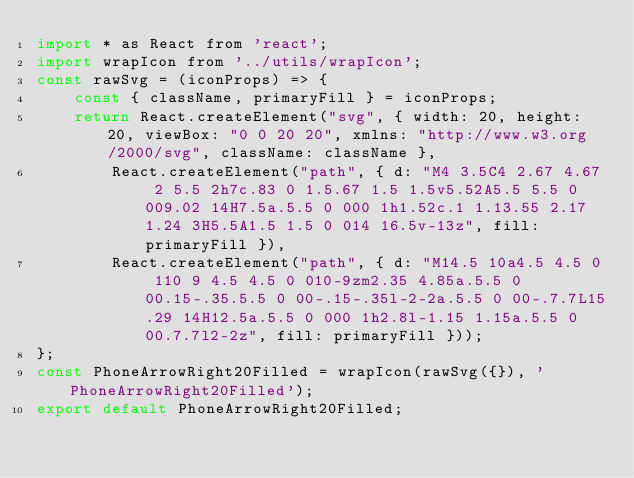<code> <loc_0><loc_0><loc_500><loc_500><_JavaScript_>import * as React from 'react';
import wrapIcon from '../utils/wrapIcon';
const rawSvg = (iconProps) => {
    const { className, primaryFill } = iconProps;
    return React.createElement("svg", { width: 20, height: 20, viewBox: "0 0 20 20", xmlns: "http://www.w3.org/2000/svg", className: className },
        React.createElement("path", { d: "M4 3.5C4 2.67 4.67 2 5.5 2h7c.83 0 1.5.67 1.5 1.5v5.52A5.5 5.5 0 009.02 14H7.5a.5.5 0 000 1h1.52c.1 1.13.55 2.17 1.24 3H5.5A1.5 1.5 0 014 16.5v-13z", fill: primaryFill }),
        React.createElement("path", { d: "M14.5 10a4.5 4.5 0 110 9 4.5 4.5 0 010-9zm2.35 4.85a.5.5 0 00.15-.35.5.5 0 00-.15-.35l-2-2a.5.5 0 00-.7.7L15.29 14H12.5a.5.5 0 000 1h2.8l-1.15 1.15a.5.5 0 00.7.7l2-2z", fill: primaryFill }));
};
const PhoneArrowRight20Filled = wrapIcon(rawSvg({}), 'PhoneArrowRight20Filled');
export default PhoneArrowRight20Filled;
</code> 